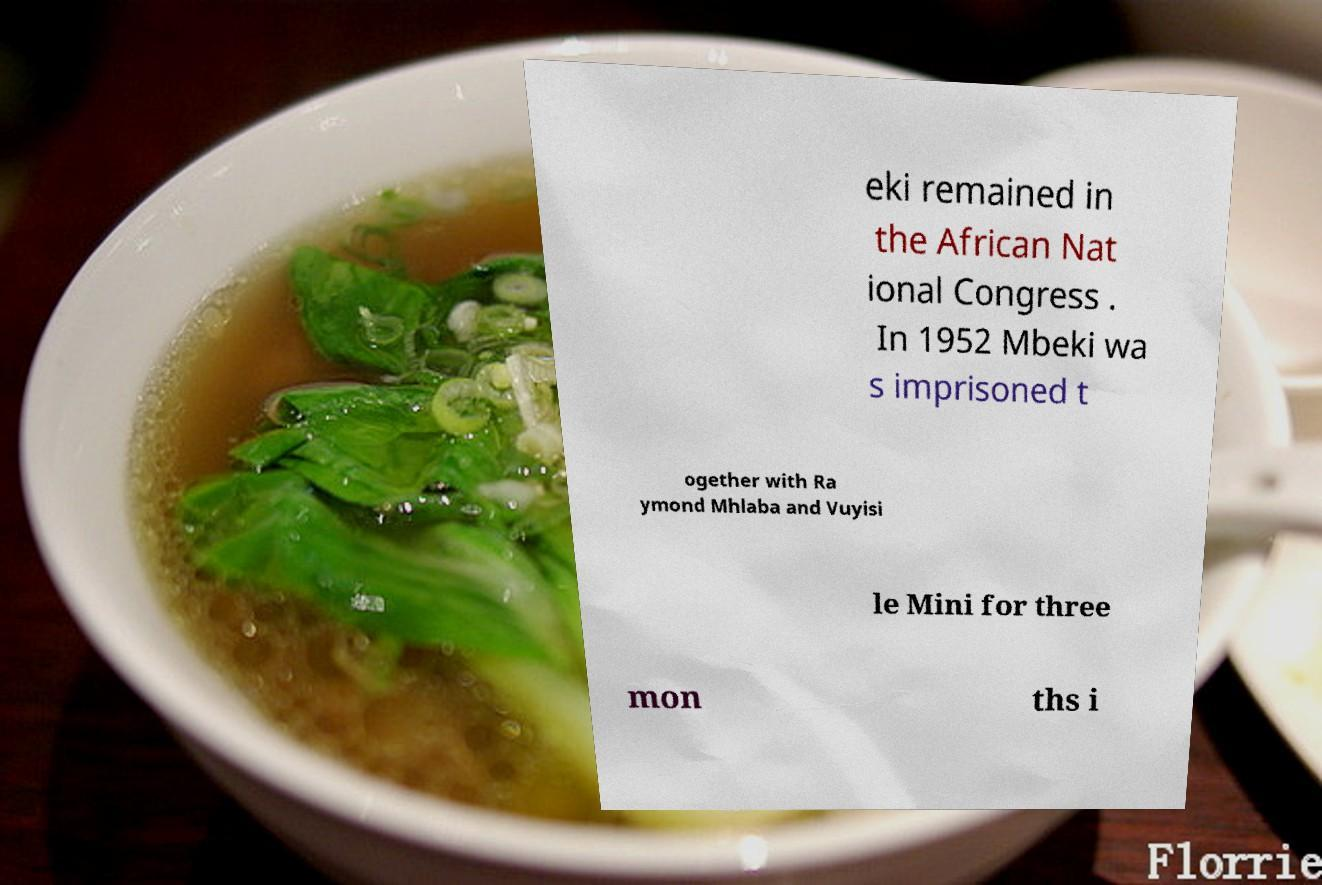Can you read and provide the text displayed in the image?This photo seems to have some interesting text. Can you extract and type it out for me? eki remained in the African Nat ional Congress . In 1952 Mbeki wa s imprisoned t ogether with Ra ymond Mhlaba and Vuyisi le Mini for three mon ths i 